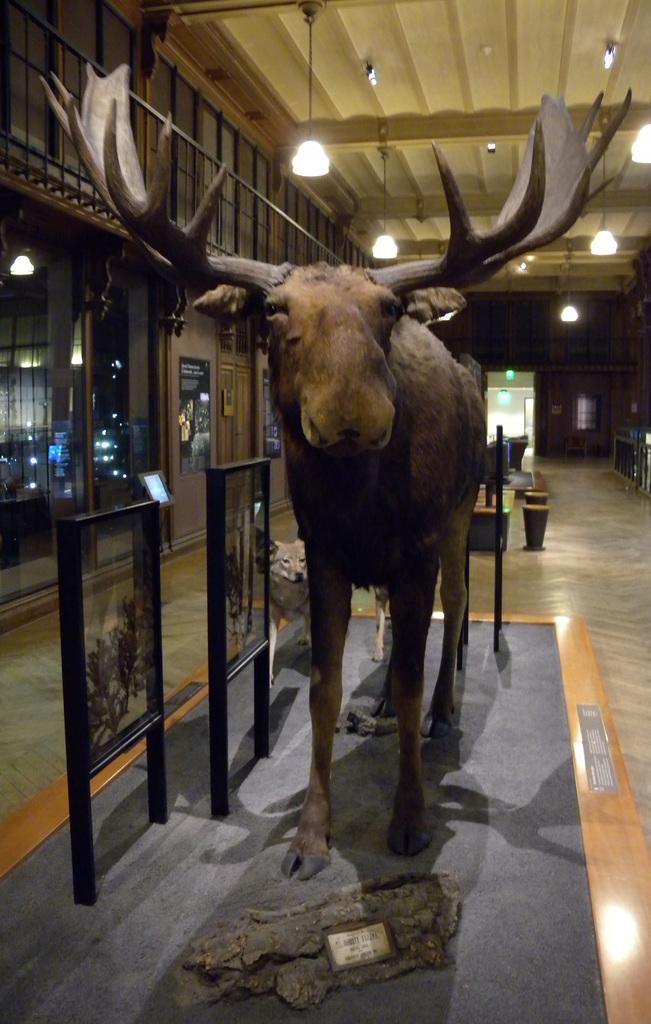Can you describe this image briefly? In this image in the center there is one toy, on the left side there are some boards, glass windows and doors. On the top there is ceiling and some lights, in the background there is a wall, lights, doors and some objects. At the bottom there is floor. 